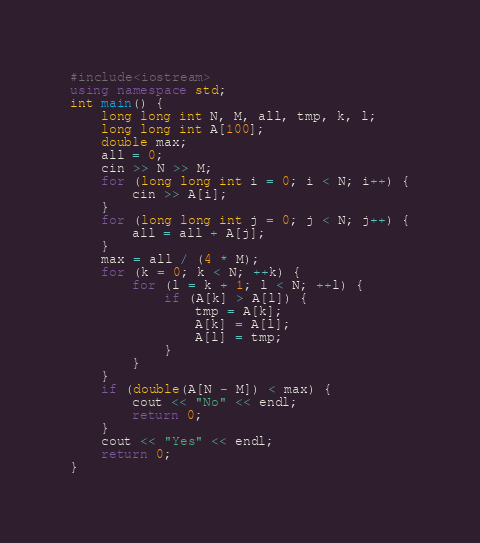<code> <loc_0><loc_0><loc_500><loc_500><_C++_>#include<iostream>
using namespace std;
int main() {
	long long int N, M, all, tmp, k, l;
	long long int A[100];
	double max;
	all = 0;
	cin >> N >> M;
	for (long long int i = 0; i < N; i++) {
		cin >> A[i];
	}
	for (long long int j = 0; j < N; j++) {
		all = all + A[j];
	}
	max = all / (4 * M);
	for (k = 0; k < N; ++k) {
		for (l = k + 1; l < N; ++l) {
			if (A[k] > A[l]) {
				tmp = A[k];
				A[k] = A[l];
				A[l] = tmp;
			}
		}
	}
	if (double(A[N - M]) < max) {
		cout << "No" << endl;
		return 0;
	}
	cout << "Yes" << endl;
    return 0;
}</code> 